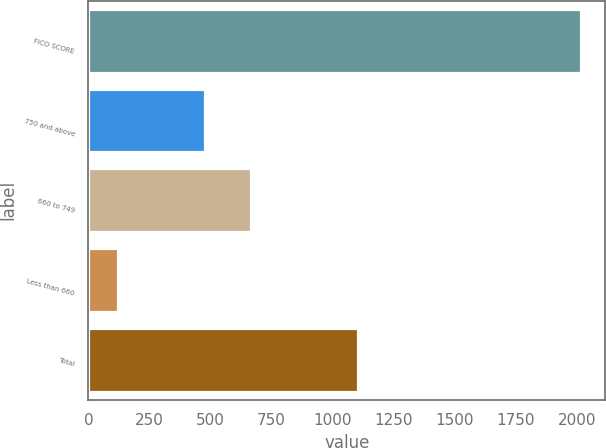<chart> <loc_0><loc_0><loc_500><loc_500><bar_chart><fcel>FICO SCORE<fcel>750 and above<fcel>660 to 749<fcel>Less than 660<fcel>Total<nl><fcel>2017<fcel>477<fcel>666.6<fcel>121<fcel>1106<nl></chart> 